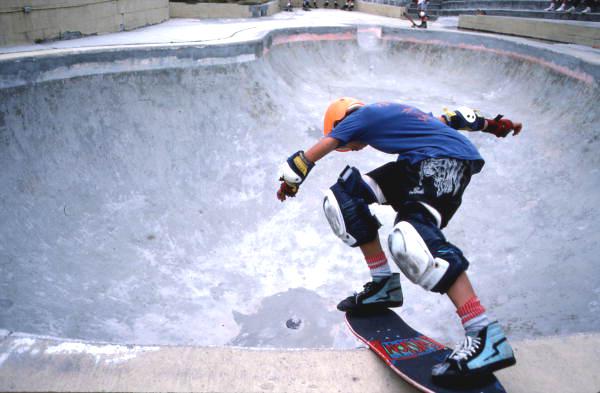Are the person's knees bent or straight?
Concise answer only. Bent. Is this a deep hole?
Answer briefly. Yes. Where is the person skating on?
Quick response, please. Skateboard. 